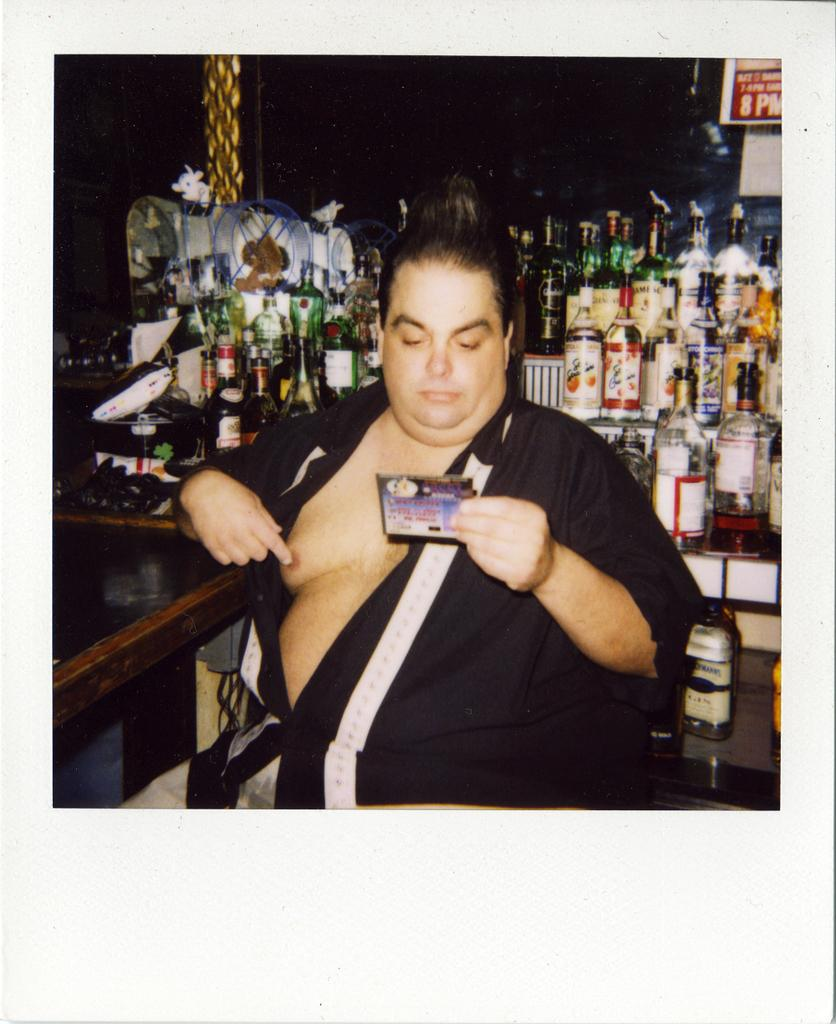Who is the main subject in the image? There is a man in the image. What objects can be seen behind the man? There are bottles behind the man. What type of riddle is the man solving in the image? There is no riddle present in the image; it only features a man and bottles. How many cents can be seen on the man's forehead in the image? There are no cents visible on the man's forehead in the image. 